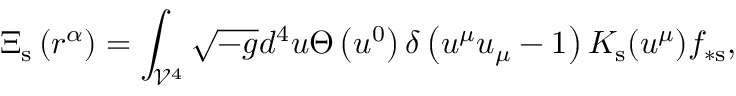<formula> <loc_0><loc_0><loc_500><loc_500>\Xi _ { s } \left ( r ^ { \alpha } \right ) = \int _ { \mathcal { V } ^ { 4 } } \sqrt { - g } d ^ { 4 } u \Theta \left ( u ^ { 0 } \right ) \delta \left ( u ^ { \mu } u _ { \mu } - 1 \right ) K _ { s } ( u ^ { \mu } ) f _ { \ast s } ,</formula> 